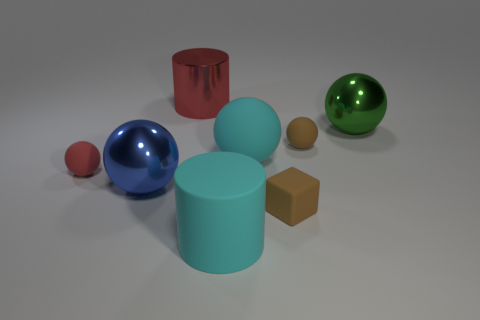Are there more red rubber objects behind the red metallic cylinder than big objects that are to the left of the small red sphere?
Offer a very short reply. No. Is there a yellow ball that has the same size as the green metallic thing?
Offer a terse response. No. What size is the shiny sphere that is behind the small sphere that is right of the shiny sphere that is in front of the green metal object?
Provide a short and direct response. Large. The shiny cylinder has what color?
Your response must be concise. Red. Is the number of big rubber cylinders that are in front of the red rubber thing greater than the number of metal spheres?
Your response must be concise. No. There is a small brown ball; what number of small matte things are in front of it?
Give a very brief answer. 2. The thing that is the same color as the tiny rubber cube is what shape?
Offer a very short reply. Sphere. Is there a big metallic thing that is in front of the red object in front of the red thing that is right of the red rubber object?
Your response must be concise. Yes. Do the brown matte ball and the brown block have the same size?
Ensure brevity in your answer.  Yes. Are there the same number of tiny objects that are behind the big red metal cylinder and balls that are in front of the large blue shiny sphere?
Make the answer very short. Yes. 